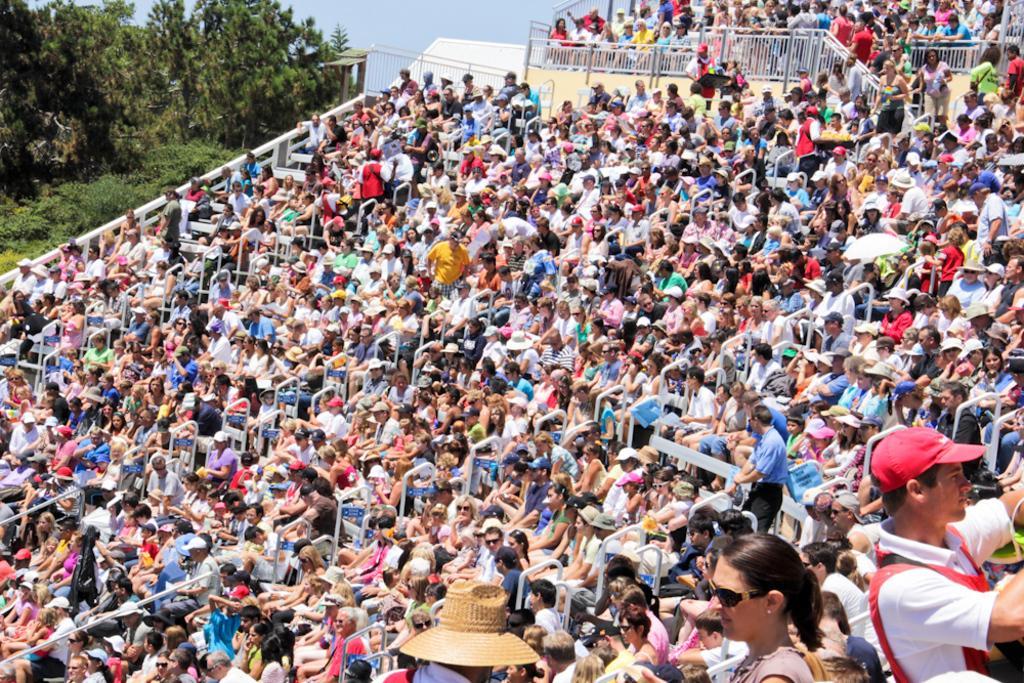Could you give a brief overview of what you see in this image? In this image, we can see a few people. Among them, some people are standing and some people are sitting. We can see the fence. There are some poles. There are some trees and plants. We can see the sky. 